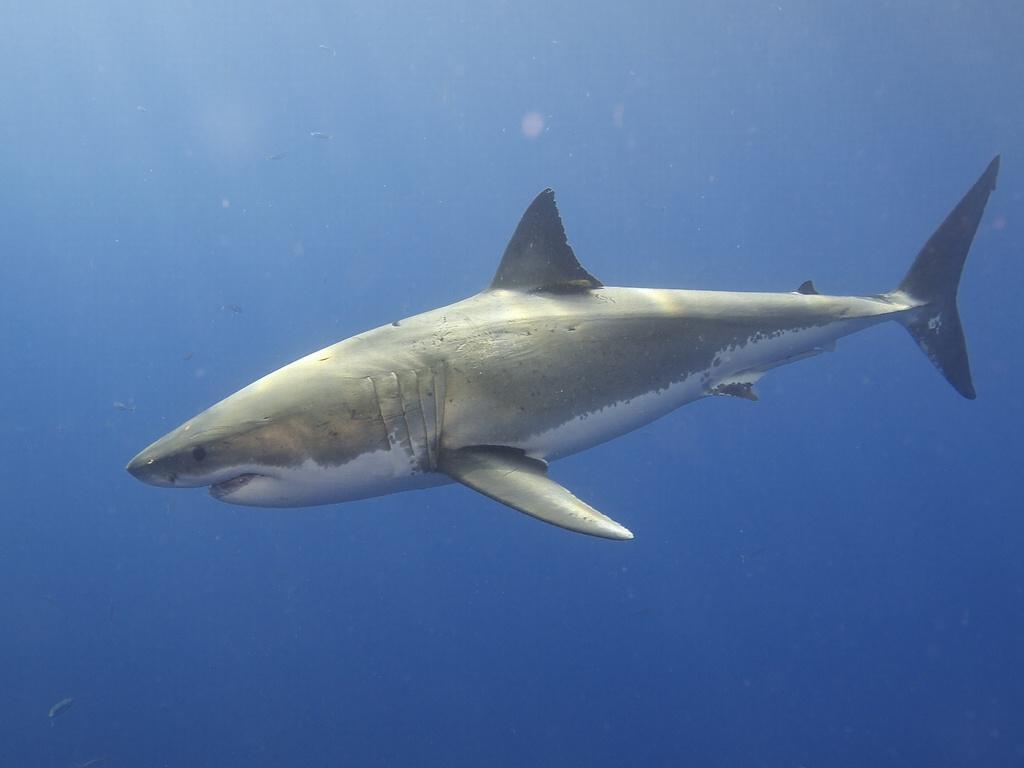In one or two sentences, can you explain what this image depicts? In this picture we can see a fish in the water. 